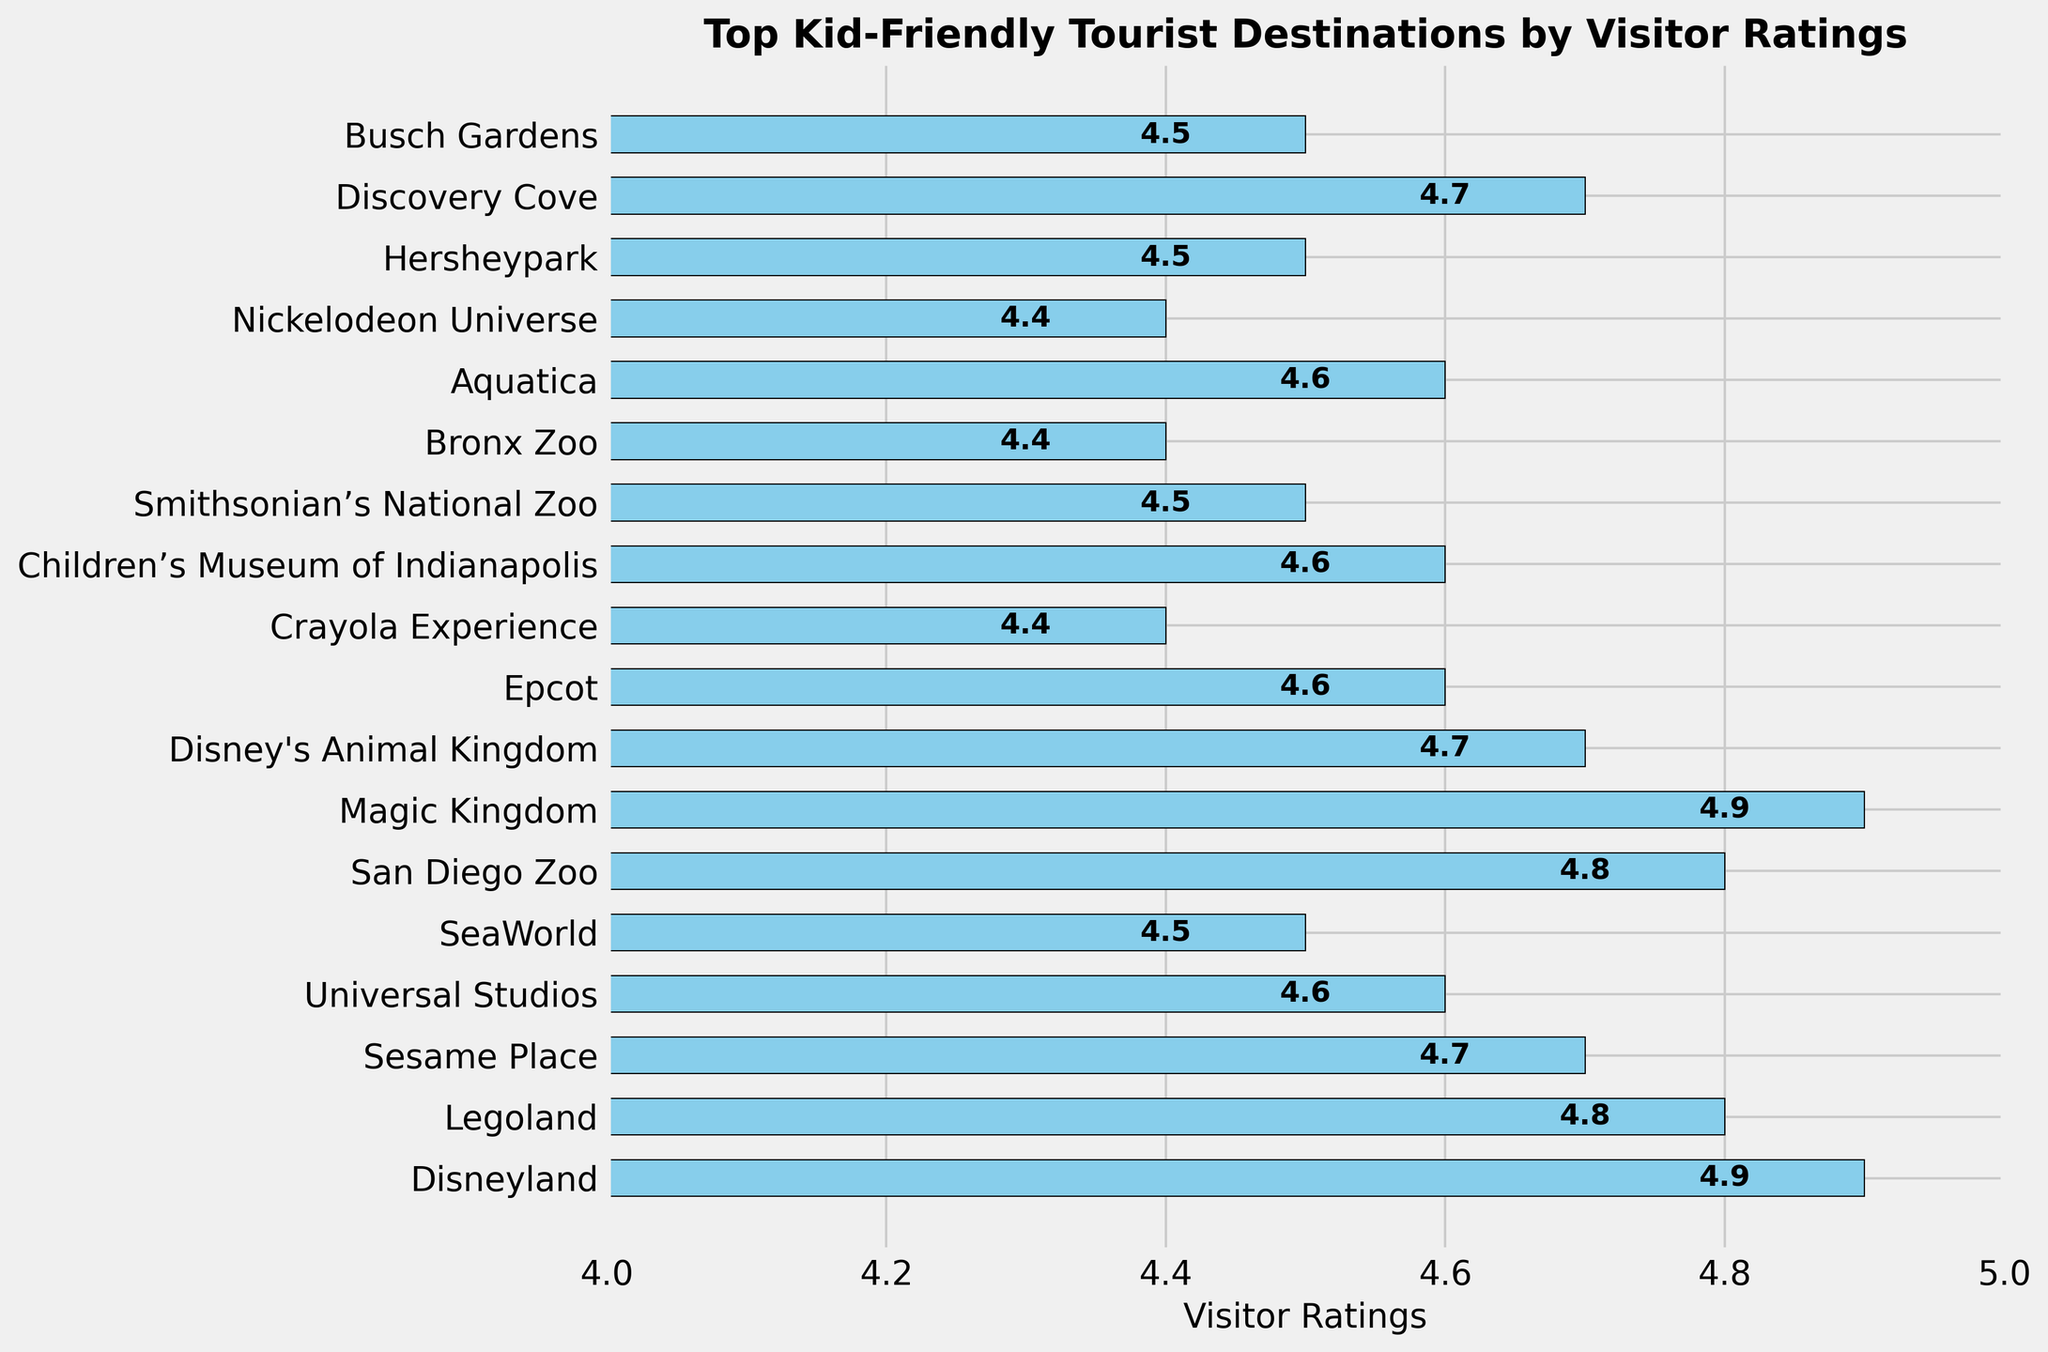Which kid-friendly destination has the highest visitor rating? To find the destination with the highest visitor rating, look for the bar that extends furthest to the right. The destination associated with this longest bar has the highest rating.
Answer: Disneyland and Magic Kingdom What’s the difference in visitor ratings between Disneyland and the Crayola Experience? To determine the difference, find the visitor ratings for both Disneyland (4.9) and the Crayola Experience (4.4) and subtract the smaller value from the larger one: 4.9 - 4.4.
Answer: 0.5 How many destinations have a visitor rating of 4.6? Count the number of bars where the ratings are labeled as 4.6. The destinations with this rating include Universal Studios, Epcot, Children’s Museum of Indianapolis, and Aquatica.
Answer: 4 Which destination has a higher rating: SeaWorld or Hersheypark? Compare the lengths of the bars corresponding to SeaWorld and Hersheypark. The labels show SeaWorld with a rating of 4.5 and Hersheypark also with 4.5.
Answer: They are equal What is the average visitor rating of Legoland, Sesame Place, and SeaWorld? Add the ratings of Legoland (4.8), Sesame Place (4.7), and SeaWorld (4.5) and divide by 3: (4.8 + 4.7 + 4.5) / 3.
Answer: 4.67 Which attraction has the lowest visitor rating and what is it? The attraction with the lowest visitor rating is represented by the shortest bar. Observing the chart, the bar for the Crayola Experience, Bronx Zoo, and Nickelodeon Universe is the shortest, all rated 4.4.
Answer: Crayola Experience, Bronx Zoo, and Nickelodeon Universe Does the Universal Studios rating fall above or below 4.7? Locate the bar for Universal Studios and check the labeled rating. Universal Studios has a rating of 4.6, which is below 4.7.
Answer: Below Are there more destinations with ratings above 4.7 or below 4.7? Count the number of bars with ratings above 4.7 (Disneyland, Legoland, Magic Kingdom, San Diego Zoo, Sesame Place, Disney's Animal Kingdom, Discovery Cove) and those below (Universal Studios, Epcot, Children’s Museum of Indianapolis, Aquatica, Crayola Experience, Bronx Zoo, Nickelodeon Universe, SeaWorld, Hersheypark, Busch Gardens).
Answer: Below 